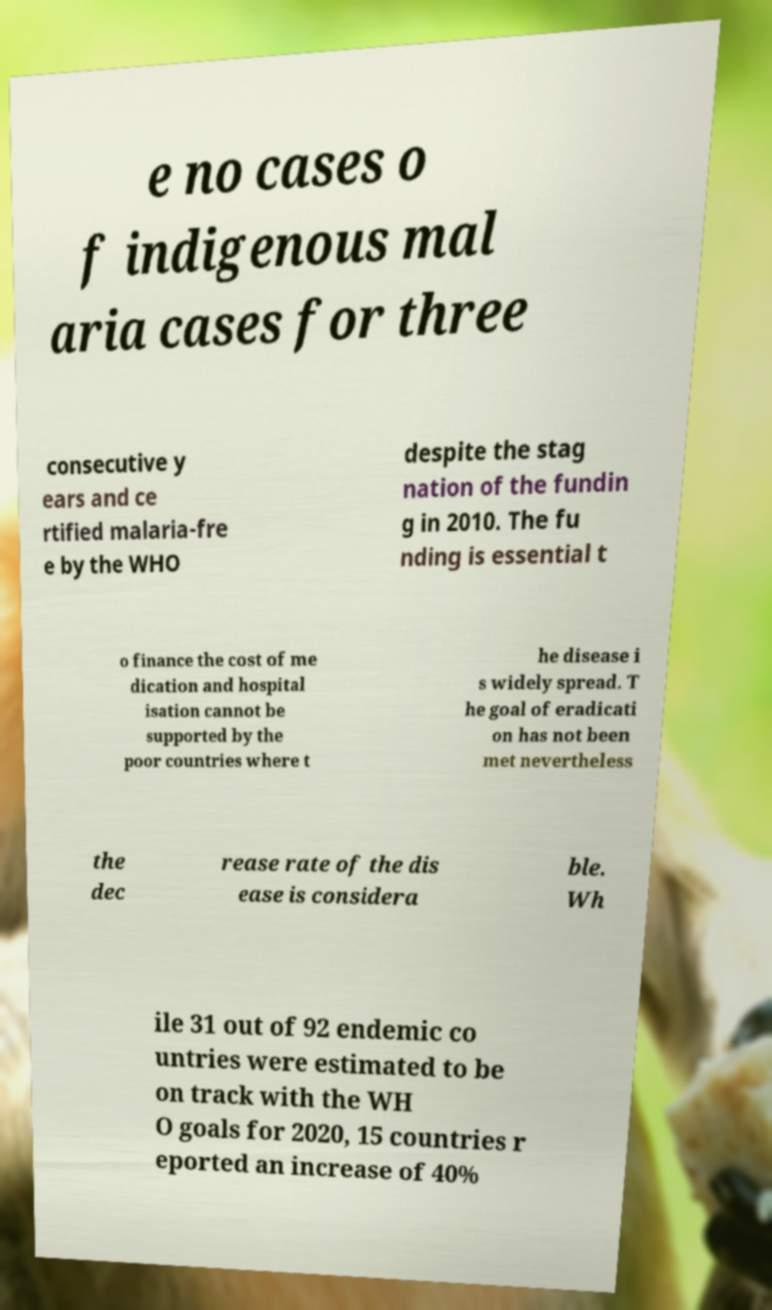Can you read and provide the text displayed in the image?This photo seems to have some interesting text. Can you extract and type it out for me? e no cases o f indigenous mal aria cases for three consecutive y ears and ce rtified malaria-fre e by the WHO despite the stag nation of the fundin g in 2010. The fu nding is essential t o finance the cost of me dication and hospital isation cannot be supported by the poor countries where t he disease i s widely spread. T he goal of eradicati on has not been met nevertheless the dec rease rate of the dis ease is considera ble. Wh ile 31 out of 92 endemic co untries were estimated to be on track with the WH O goals for 2020, 15 countries r eported an increase of 40% 